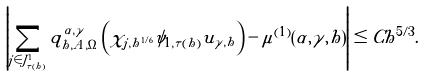Convert formula to latex. <formula><loc_0><loc_0><loc_500><loc_500>\left | \sum _ { j \in J ^ { 1 } _ { \tau ( h ) } } q ^ { \alpha , \gamma } _ { h , A , \Omega } \left ( \chi _ { j , h ^ { 1 / 6 } } \psi _ { 1 , \tau ( h ) } u _ { \gamma , h } \right ) - \mu ^ { ( 1 ) } ( \alpha , \gamma , h ) \right | \leq C h ^ { 5 / 3 } .</formula> 